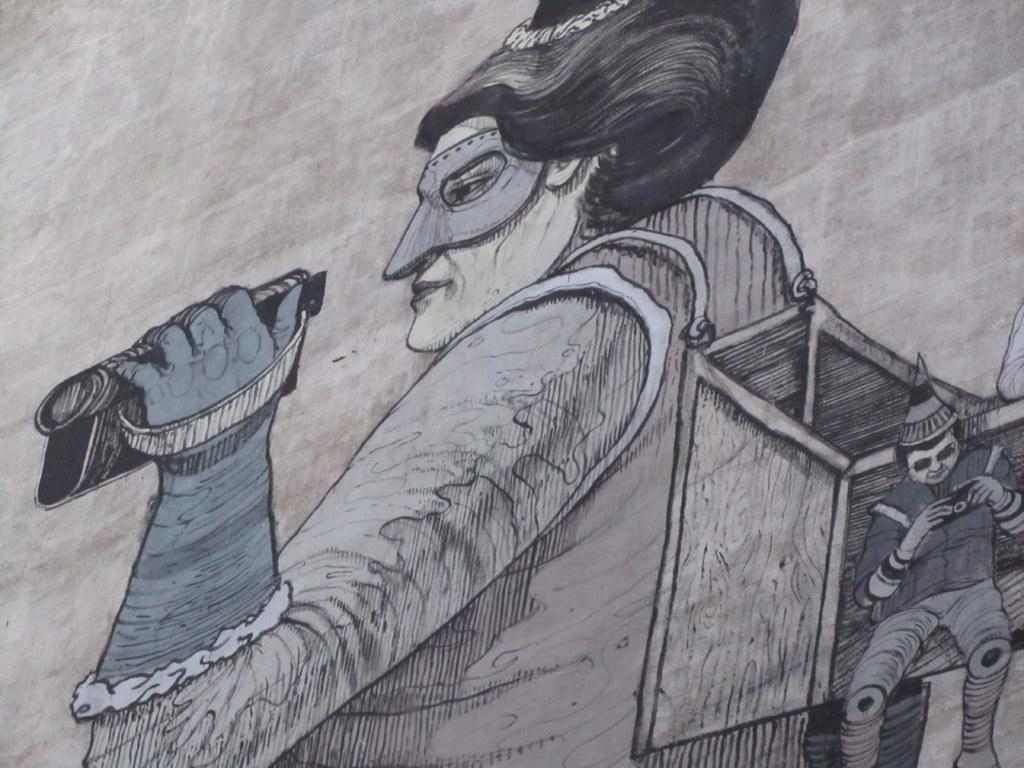What is the main subject in the center of the image? There is a sketch in the center of the image. Where is the sketch located? The sketch is on a wall. What is the result of adding the power of the sketch to the distance it can travel? There is no information about the power or distance of the sketch in the image, as it is a static sketch on a wall. 